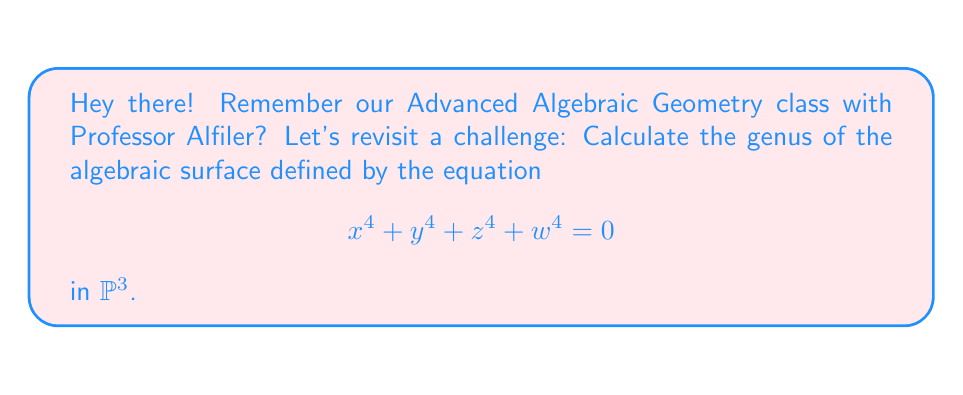Can you answer this question? Let's approach this step-by-step:

1) First, recall the formula for the genus of a smooth surface $S$ in $\mathbb{P}^3$:

   $$ g(S) = \frac{1}{2}(d-1)(d-2)(d-3) + 1 $$

   where $d$ is the degree of the surface.

2) In our case, the surface is defined by a homogeneous polynomial of degree 4:

   $$ x^4 + y^4 + z^4 + w^4 = 0 $$

   So, $d = 4$.

3) Let's substitute $d = 4$ into our formula:

   $$ g(S) = \frac{1}{2}(4-1)(4-2)(4-3) + 1 $$

4) Simplify:
   $$ g(S) = \frac{1}{2}(3)(2)(1) + 1 $$
   $$ g(S) = \frac{1}{2}(6) + 1 $$
   $$ g(S) = 3 + 1 $$
   $$ g(S) = 4 $$

5) Therefore, the genus of the surface is 4.

Note: This calculation assumes the surface is smooth. In this case, it is indeed smooth, as can be verified by checking that the partial derivatives don't simultaneously vanish at any point on the surface.
Answer: 4 